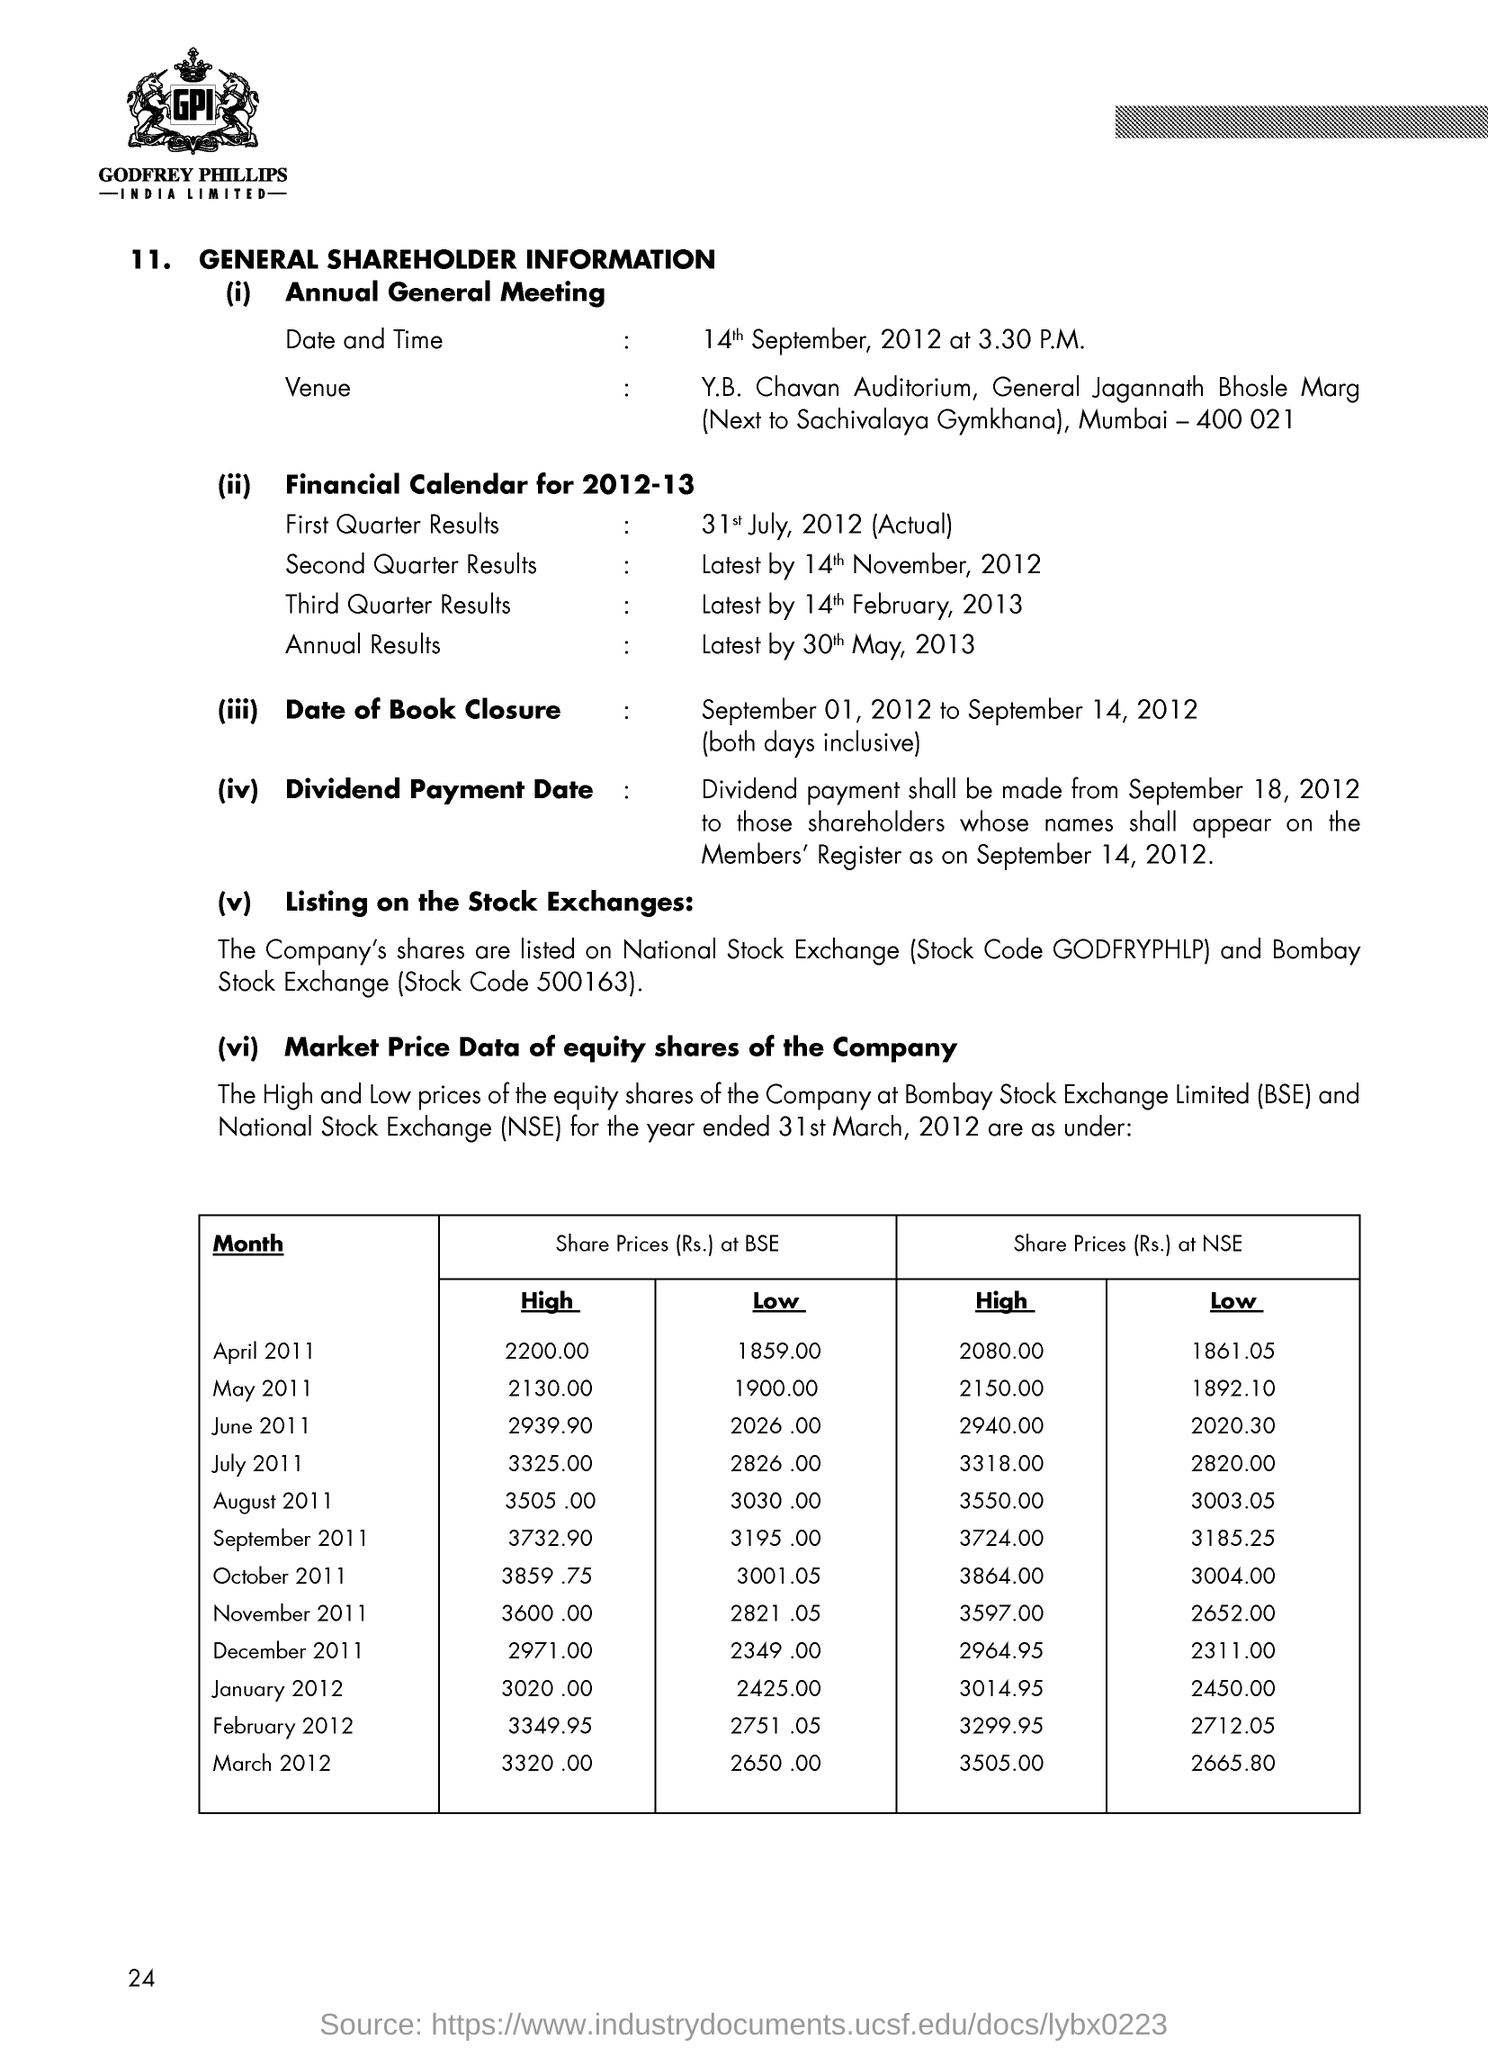Identify some key points in this picture. The annual general meeting will take place on September 14, 2012, at 3:30 p.m. 